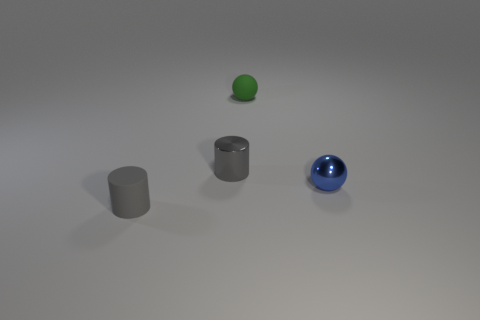Are the objects arranged in a specific pattern? The objects are placed somewhat equidistantly in a diagonal line across the image from the bottom left to the top right. This arrangement creates a sense of balanced composition within the frame. Can you describe the lighting or shadows in the image? The objects cast soft-edged shadows towards the right of the frame, suggesting a diffuse light source coming from the left. The shadows contribute to the depth and realism of the scene. 